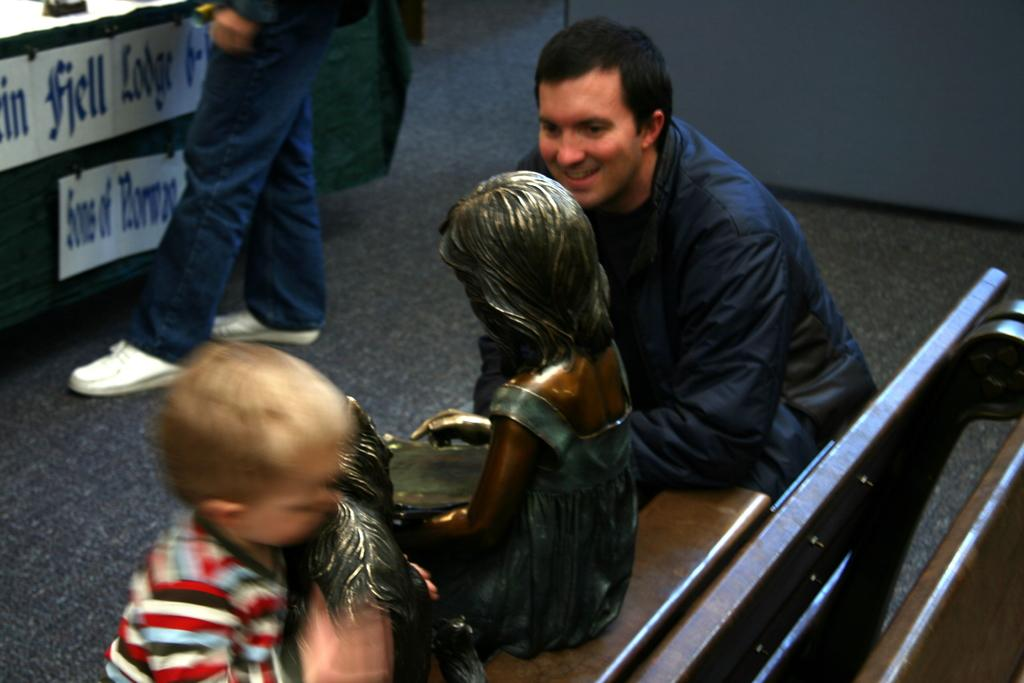Who or what can be seen in the image? There are people in the image. What object is sitting on a bench in the image? There is a sculpture sitting on a bench in the image. What type of structure is visible in the image? There is a wall in the image. What surface is under the people and sculpture? There is a floor in the image. What can be seen on a green surface in the image? There are boards on a green surface in the image. What type of oven is used to cook the boards on a green surface in the image? There is no oven present in the image, and the boards on a green surface are not being cooked. 